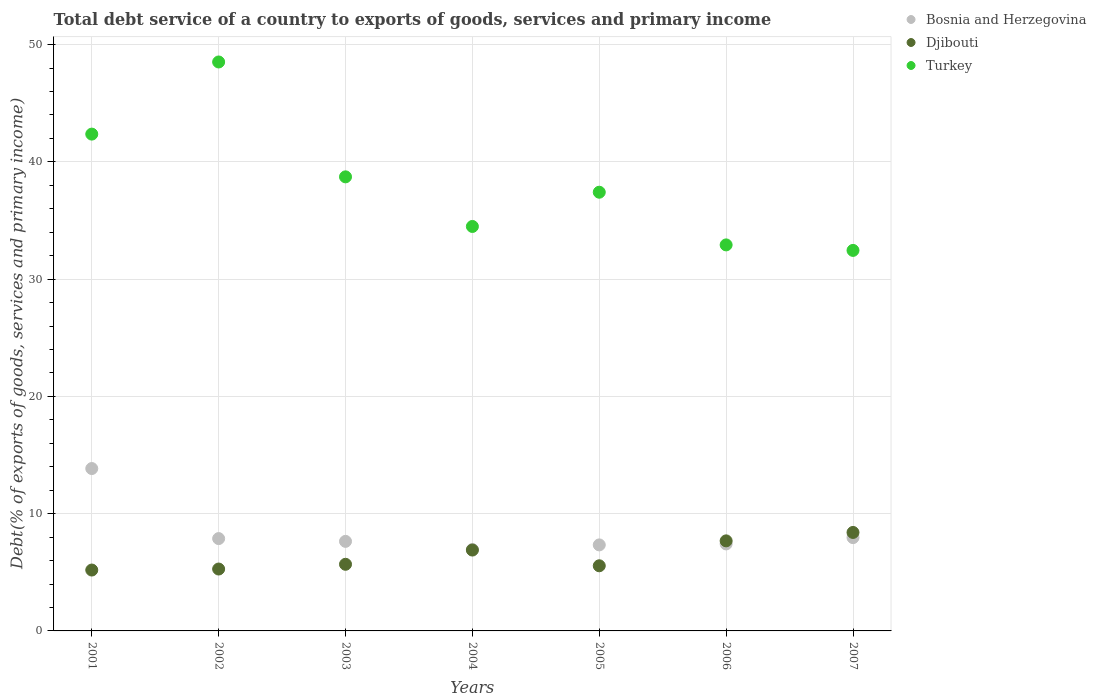How many different coloured dotlines are there?
Give a very brief answer. 3. What is the total debt service in Turkey in 2007?
Ensure brevity in your answer.  32.45. Across all years, what is the maximum total debt service in Bosnia and Herzegovina?
Provide a succinct answer. 13.85. Across all years, what is the minimum total debt service in Bosnia and Herzegovina?
Provide a succinct answer. 6.94. What is the total total debt service in Djibouti in the graph?
Offer a very short reply. 44.68. What is the difference between the total debt service in Bosnia and Herzegovina in 2004 and that in 2005?
Give a very brief answer. -0.39. What is the difference between the total debt service in Bosnia and Herzegovina in 2002 and the total debt service in Turkey in 2005?
Offer a terse response. -29.54. What is the average total debt service in Djibouti per year?
Ensure brevity in your answer.  6.38. In the year 2004, what is the difference between the total debt service in Bosnia and Herzegovina and total debt service in Djibouti?
Provide a succinct answer. 0.05. In how many years, is the total debt service in Bosnia and Herzegovina greater than 30 %?
Ensure brevity in your answer.  0. What is the ratio of the total debt service in Djibouti in 2003 to that in 2006?
Offer a very short reply. 0.74. Is the total debt service in Turkey in 2002 less than that in 2005?
Give a very brief answer. No. What is the difference between the highest and the second highest total debt service in Turkey?
Offer a terse response. 6.15. What is the difference between the highest and the lowest total debt service in Turkey?
Give a very brief answer. 16.07. Is the sum of the total debt service in Turkey in 2002 and 2007 greater than the maximum total debt service in Djibouti across all years?
Your answer should be compact. Yes. Is it the case that in every year, the sum of the total debt service in Djibouti and total debt service in Bosnia and Herzegovina  is greater than the total debt service in Turkey?
Your response must be concise. No. Does the total debt service in Djibouti monotonically increase over the years?
Your response must be concise. No. Is the total debt service in Djibouti strictly greater than the total debt service in Turkey over the years?
Offer a very short reply. No. Does the graph contain any zero values?
Your answer should be very brief. No. Does the graph contain grids?
Offer a very short reply. Yes. Where does the legend appear in the graph?
Your answer should be compact. Top right. How are the legend labels stacked?
Ensure brevity in your answer.  Vertical. What is the title of the graph?
Offer a terse response. Total debt service of a country to exports of goods, services and primary income. What is the label or title of the Y-axis?
Keep it short and to the point. Debt(% of exports of goods, services and primary income). What is the Debt(% of exports of goods, services and primary income) of Bosnia and Herzegovina in 2001?
Keep it short and to the point. 13.85. What is the Debt(% of exports of goods, services and primary income) of Djibouti in 2001?
Offer a terse response. 5.19. What is the Debt(% of exports of goods, services and primary income) of Turkey in 2001?
Your answer should be compact. 42.37. What is the Debt(% of exports of goods, services and primary income) in Bosnia and Herzegovina in 2002?
Your answer should be compact. 7.87. What is the Debt(% of exports of goods, services and primary income) in Djibouti in 2002?
Your answer should be compact. 5.28. What is the Debt(% of exports of goods, services and primary income) in Turkey in 2002?
Your answer should be very brief. 48.52. What is the Debt(% of exports of goods, services and primary income) of Bosnia and Herzegovina in 2003?
Offer a very short reply. 7.64. What is the Debt(% of exports of goods, services and primary income) of Djibouti in 2003?
Your answer should be very brief. 5.68. What is the Debt(% of exports of goods, services and primary income) of Turkey in 2003?
Your answer should be very brief. 38.72. What is the Debt(% of exports of goods, services and primary income) of Bosnia and Herzegovina in 2004?
Provide a succinct answer. 6.94. What is the Debt(% of exports of goods, services and primary income) in Djibouti in 2004?
Your answer should be very brief. 6.9. What is the Debt(% of exports of goods, services and primary income) in Turkey in 2004?
Offer a terse response. 34.49. What is the Debt(% of exports of goods, services and primary income) of Bosnia and Herzegovina in 2005?
Your answer should be very brief. 7.34. What is the Debt(% of exports of goods, services and primary income) in Djibouti in 2005?
Give a very brief answer. 5.55. What is the Debt(% of exports of goods, services and primary income) of Turkey in 2005?
Your answer should be very brief. 37.41. What is the Debt(% of exports of goods, services and primary income) in Bosnia and Herzegovina in 2006?
Offer a terse response. 7.42. What is the Debt(% of exports of goods, services and primary income) of Djibouti in 2006?
Keep it short and to the point. 7.68. What is the Debt(% of exports of goods, services and primary income) of Turkey in 2006?
Provide a succinct answer. 32.92. What is the Debt(% of exports of goods, services and primary income) in Bosnia and Herzegovina in 2007?
Your response must be concise. 7.96. What is the Debt(% of exports of goods, services and primary income) of Djibouti in 2007?
Make the answer very short. 8.4. What is the Debt(% of exports of goods, services and primary income) in Turkey in 2007?
Keep it short and to the point. 32.45. Across all years, what is the maximum Debt(% of exports of goods, services and primary income) in Bosnia and Herzegovina?
Give a very brief answer. 13.85. Across all years, what is the maximum Debt(% of exports of goods, services and primary income) in Djibouti?
Your answer should be very brief. 8.4. Across all years, what is the maximum Debt(% of exports of goods, services and primary income) in Turkey?
Ensure brevity in your answer.  48.52. Across all years, what is the minimum Debt(% of exports of goods, services and primary income) in Bosnia and Herzegovina?
Offer a terse response. 6.94. Across all years, what is the minimum Debt(% of exports of goods, services and primary income) of Djibouti?
Offer a very short reply. 5.19. Across all years, what is the minimum Debt(% of exports of goods, services and primary income) in Turkey?
Offer a very short reply. 32.45. What is the total Debt(% of exports of goods, services and primary income) in Bosnia and Herzegovina in the graph?
Offer a terse response. 59.01. What is the total Debt(% of exports of goods, services and primary income) of Djibouti in the graph?
Provide a succinct answer. 44.68. What is the total Debt(% of exports of goods, services and primary income) of Turkey in the graph?
Offer a terse response. 266.89. What is the difference between the Debt(% of exports of goods, services and primary income) of Bosnia and Herzegovina in 2001 and that in 2002?
Provide a succinct answer. 5.97. What is the difference between the Debt(% of exports of goods, services and primary income) of Djibouti in 2001 and that in 2002?
Offer a terse response. -0.09. What is the difference between the Debt(% of exports of goods, services and primary income) in Turkey in 2001 and that in 2002?
Give a very brief answer. -6.15. What is the difference between the Debt(% of exports of goods, services and primary income) in Bosnia and Herzegovina in 2001 and that in 2003?
Provide a succinct answer. 6.21. What is the difference between the Debt(% of exports of goods, services and primary income) of Djibouti in 2001 and that in 2003?
Your response must be concise. -0.49. What is the difference between the Debt(% of exports of goods, services and primary income) in Turkey in 2001 and that in 2003?
Ensure brevity in your answer.  3.64. What is the difference between the Debt(% of exports of goods, services and primary income) in Bosnia and Herzegovina in 2001 and that in 2004?
Your answer should be very brief. 6.9. What is the difference between the Debt(% of exports of goods, services and primary income) of Djibouti in 2001 and that in 2004?
Provide a short and direct response. -1.7. What is the difference between the Debt(% of exports of goods, services and primary income) of Turkey in 2001 and that in 2004?
Your response must be concise. 7.88. What is the difference between the Debt(% of exports of goods, services and primary income) in Bosnia and Herzegovina in 2001 and that in 2005?
Give a very brief answer. 6.51. What is the difference between the Debt(% of exports of goods, services and primary income) of Djibouti in 2001 and that in 2005?
Your answer should be very brief. -0.36. What is the difference between the Debt(% of exports of goods, services and primary income) in Turkey in 2001 and that in 2005?
Provide a succinct answer. 4.96. What is the difference between the Debt(% of exports of goods, services and primary income) of Bosnia and Herzegovina in 2001 and that in 2006?
Your answer should be compact. 6.43. What is the difference between the Debt(% of exports of goods, services and primary income) in Djibouti in 2001 and that in 2006?
Offer a very short reply. -2.49. What is the difference between the Debt(% of exports of goods, services and primary income) in Turkey in 2001 and that in 2006?
Provide a short and direct response. 9.45. What is the difference between the Debt(% of exports of goods, services and primary income) of Bosnia and Herzegovina in 2001 and that in 2007?
Offer a very short reply. 5.89. What is the difference between the Debt(% of exports of goods, services and primary income) of Djibouti in 2001 and that in 2007?
Your response must be concise. -3.21. What is the difference between the Debt(% of exports of goods, services and primary income) in Turkey in 2001 and that in 2007?
Make the answer very short. 9.92. What is the difference between the Debt(% of exports of goods, services and primary income) in Bosnia and Herzegovina in 2002 and that in 2003?
Provide a succinct answer. 0.24. What is the difference between the Debt(% of exports of goods, services and primary income) in Djibouti in 2002 and that in 2003?
Provide a succinct answer. -0.4. What is the difference between the Debt(% of exports of goods, services and primary income) in Turkey in 2002 and that in 2003?
Offer a terse response. 9.8. What is the difference between the Debt(% of exports of goods, services and primary income) in Bosnia and Herzegovina in 2002 and that in 2004?
Provide a short and direct response. 0.93. What is the difference between the Debt(% of exports of goods, services and primary income) in Djibouti in 2002 and that in 2004?
Ensure brevity in your answer.  -1.62. What is the difference between the Debt(% of exports of goods, services and primary income) in Turkey in 2002 and that in 2004?
Offer a terse response. 14.03. What is the difference between the Debt(% of exports of goods, services and primary income) in Bosnia and Herzegovina in 2002 and that in 2005?
Ensure brevity in your answer.  0.54. What is the difference between the Debt(% of exports of goods, services and primary income) in Djibouti in 2002 and that in 2005?
Keep it short and to the point. -0.28. What is the difference between the Debt(% of exports of goods, services and primary income) of Turkey in 2002 and that in 2005?
Provide a short and direct response. 11.11. What is the difference between the Debt(% of exports of goods, services and primary income) of Bosnia and Herzegovina in 2002 and that in 2006?
Your answer should be very brief. 0.46. What is the difference between the Debt(% of exports of goods, services and primary income) of Djibouti in 2002 and that in 2006?
Provide a short and direct response. -2.4. What is the difference between the Debt(% of exports of goods, services and primary income) in Turkey in 2002 and that in 2006?
Your response must be concise. 15.6. What is the difference between the Debt(% of exports of goods, services and primary income) of Bosnia and Herzegovina in 2002 and that in 2007?
Your answer should be very brief. -0.08. What is the difference between the Debt(% of exports of goods, services and primary income) of Djibouti in 2002 and that in 2007?
Your answer should be compact. -3.12. What is the difference between the Debt(% of exports of goods, services and primary income) of Turkey in 2002 and that in 2007?
Your answer should be compact. 16.07. What is the difference between the Debt(% of exports of goods, services and primary income) in Bosnia and Herzegovina in 2003 and that in 2004?
Your answer should be compact. 0.69. What is the difference between the Debt(% of exports of goods, services and primary income) of Djibouti in 2003 and that in 2004?
Keep it short and to the point. -1.21. What is the difference between the Debt(% of exports of goods, services and primary income) in Turkey in 2003 and that in 2004?
Ensure brevity in your answer.  4.23. What is the difference between the Debt(% of exports of goods, services and primary income) in Bosnia and Herzegovina in 2003 and that in 2005?
Your answer should be very brief. 0.3. What is the difference between the Debt(% of exports of goods, services and primary income) in Djibouti in 2003 and that in 2005?
Provide a short and direct response. 0.13. What is the difference between the Debt(% of exports of goods, services and primary income) in Turkey in 2003 and that in 2005?
Your answer should be very brief. 1.31. What is the difference between the Debt(% of exports of goods, services and primary income) of Bosnia and Herzegovina in 2003 and that in 2006?
Your answer should be very brief. 0.22. What is the difference between the Debt(% of exports of goods, services and primary income) of Djibouti in 2003 and that in 2006?
Your answer should be compact. -2. What is the difference between the Debt(% of exports of goods, services and primary income) of Turkey in 2003 and that in 2006?
Make the answer very short. 5.8. What is the difference between the Debt(% of exports of goods, services and primary income) of Bosnia and Herzegovina in 2003 and that in 2007?
Your answer should be very brief. -0.32. What is the difference between the Debt(% of exports of goods, services and primary income) in Djibouti in 2003 and that in 2007?
Your answer should be very brief. -2.72. What is the difference between the Debt(% of exports of goods, services and primary income) of Turkey in 2003 and that in 2007?
Give a very brief answer. 6.27. What is the difference between the Debt(% of exports of goods, services and primary income) in Bosnia and Herzegovina in 2004 and that in 2005?
Provide a short and direct response. -0.39. What is the difference between the Debt(% of exports of goods, services and primary income) of Djibouti in 2004 and that in 2005?
Your response must be concise. 1.34. What is the difference between the Debt(% of exports of goods, services and primary income) of Turkey in 2004 and that in 2005?
Provide a succinct answer. -2.92. What is the difference between the Debt(% of exports of goods, services and primary income) in Bosnia and Herzegovina in 2004 and that in 2006?
Your answer should be very brief. -0.47. What is the difference between the Debt(% of exports of goods, services and primary income) in Djibouti in 2004 and that in 2006?
Keep it short and to the point. -0.78. What is the difference between the Debt(% of exports of goods, services and primary income) in Turkey in 2004 and that in 2006?
Keep it short and to the point. 1.57. What is the difference between the Debt(% of exports of goods, services and primary income) of Bosnia and Herzegovina in 2004 and that in 2007?
Give a very brief answer. -1.01. What is the difference between the Debt(% of exports of goods, services and primary income) of Djibouti in 2004 and that in 2007?
Your answer should be very brief. -1.5. What is the difference between the Debt(% of exports of goods, services and primary income) in Turkey in 2004 and that in 2007?
Your answer should be very brief. 2.04. What is the difference between the Debt(% of exports of goods, services and primary income) of Bosnia and Herzegovina in 2005 and that in 2006?
Provide a succinct answer. -0.08. What is the difference between the Debt(% of exports of goods, services and primary income) of Djibouti in 2005 and that in 2006?
Make the answer very short. -2.13. What is the difference between the Debt(% of exports of goods, services and primary income) in Turkey in 2005 and that in 2006?
Provide a short and direct response. 4.49. What is the difference between the Debt(% of exports of goods, services and primary income) of Bosnia and Herzegovina in 2005 and that in 2007?
Offer a very short reply. -0.62. What is the difference between the Debt(% of exports of goods, services and primary income) in Djibouti in 2005 and that in 2007?
Offer a very short reply. -2.84. What is the difference between the Debt(% of exports of goods, services and primary income) of Turkey in 2005 and that in 2007?
Offer a terse response. 4.96. What is the difference between the Debt(% of exports of goods, services and primary income) in Bosnia and Herzegovina in 2006 and that in 2007?
Provide a short and direct response. -0.54. What is the difference between the Debt(% of exports of goods, services and primary income) in Djibouti in 2006 and that in 2007?
Make the answer very short. -0.72. What is the difference between the Debt(% of exports of goods, services and primary income) in Turkey in 2006 and that in 2007?
Your response must be concise. 0.47. What is the difference between the Debt(% of exports of goods, services and primary income) in Bosnia and Herzegovina in 2001 and the Debt(% of exports of goods, services and primary income) in Djibouti in 2002?
Offer a terse response. 8.57. What is the difference between the Debt(% of exports of goods, services and primary income) of Bosnia and Herzegovina in 2001 and the Debt(% of exports of goods, services and primary income) of Turkey in 2002?
Your answer should be compact. -34.67. What is the difference between the Debt(% of exports of goods, services and primary income) in Djibouti in 2001 and the Debt(% of exports of goods, services and primary income) in Turkey in 2002?
Offer a very short reply. -43.33. What is the difference between the Debt(% of exports of goods, services and primary income) of Bosnia and Herzegovina in 2001 and the Debt(% of exports of goods, services and primary income) of Djibouti in 2003?
Provide a succinct answer. 8.17. What is the difference between the Debt(% of exports of goods, services and primary income) of Bosnia and Herzegovina in 2001 and the Debt(% of exports of goods, services and primary income) of Turkey in 2003?
Your response must be concise. -24.88. What is the difference between the Debt(% of exports of goods, services and primary income) in Djibouti in 2001 and the Debt(% of exports of goods, services and primary income) in Turkey in 2003?
Give a very brief answer. -33.53. What is the difference between the Debt(% of exports of goods, services and primary income) of Bosnia and Herzegovina in 2001 and the Debt(% of exports of goods, services and primary income) of Djibouti in 2004?
Offer a terse response. 6.95. What is the difference between the Debt(% of exports of goods, services and primary income) of Bosnia and Herzegovina in 2001 and the Debt(% of exports of goods, services and primary income) of Turkey in 2004?
Your answer should be compact. -20.64. What is the difference between the Debt(% of exports of goods, services and primary income) in Djibouti in 2001 and the Debt(% of exports of goods, services and primary income) in Turkey in 2004?
Ensure brevity in your answer.  -29.3. What is the difference between the Debt(% of exports of goods, services and primary income) in Bosnia and Herzegovina in 2001 and the Debt(% of exports of goods, services and primary income) in Djibouti in 2005?
Give a very brief answer. 8.29. What is the difference between the Debt(% of exports of goods, services and primary income) in Bosnia and Herzegovina in 2001 and the Debt(% of exports of goods, services and primary income) in Turkey in 2005?
Offer a terse response. -23.56. What is the difference between the Debt(% of exports of goods, services and primary income) of Djibouti in 2001 and the Debt(% of exports of goods, services and primary income) of Turkey in 2005?
Keep it short and to the point. -32.22. What is the difference between the Debt(% of exports of goods, services and primary income) of Bosnia and Herzegovina in 2001 and the Debt(% of exports of goods, services and primary income) of Djibouti in 2006?
Your answer should be very brief. 6.17. What is the difference between the Debt(% of exports of goods, services and primary income) in Bosnia and Herzegovina in 2001 and the Debt(% of exports of goods, services and primary income) in Turkey in 2006?
Offer a very short reply. -19.07. What is the difference between the Debt(% of exports of goods, services and primary income) of Djibouti in 2001 and the Debt(% of exports of goods, services and primary income) of Turkey in 2006?
Your answer should be compact. -27.73. What is the difference between the Debt(% of exports of goods, services and primary income) of Bosnia and Herzegovina in 2001 and the Debt(% of exports of goods, services and primary income) of Djibouti in 2007?
Provide a succinct answer. 5.45. What is the difference between the Debt(% of exports of goods, services and primary income) in Bosnia and Herzegovina in 2001 and the Debt(% of exports of goods, services and primary income) in Turkey in 2007?
Your answer should be very brief. -18.6. What is the difference between the Debt(% of exports of goods, services and primary income) in Djibouti in 2001 and the Debt(% of exports of goods, services and primary income) in Turkey in 2007?
Provide a short and direct response. -27.26. What is the difference between the Debt(% of exports of goods, services and primary income) of Bosnia and Herzegovina in 2002 and the Debt(% of exports of goods, services and primary income) of Djibouti in 2003?
Give a very brief answer. 2.19. What is the difference between the Debt(% of exports of goods, services and primary income) of Bosnia and Herzegovina in 2002 and the Debt(% of exports of goods, services and primary income) of Turkey in 2003?
Your response must be concise. -30.85. What is the difference between the Debt(% of exports of goods, services and primary income) of Djibouti in 2002 and the Debt(% of exports of goods, services and primary income) of Turkey in 2003?
Your response must be concise. -33.45. What is the difference between the Debt(% of exports of goods, services and primary income) in Bosnia and Herzegovina in 2002 and the Debt(% of exports of goods, services and primary income) in Djibouti in 2004?
Give a very brief answer. 0.98. What is the difference between the Debt(% of exports of goods, services and primary income) in Bosnia and Herzegovina in 2002 and the Debt(% of exports of goods, services and primary income) in Turkey in 2004?
Make the answer very short. -26.62. What is the difference between the Debt(% of exports of goods, services and primary income) of Djibouti in 2002 and the Debt(% of exports of goods, services and primary income) of Turkey in 2004?
Provide a succinct answer. -29.21. What is the difference between the Debt(% of exports of goods, services and primary income) in Bosnia and Herzegovina in 2002 and the Debt(% of exports of goods, services and primary income) in Djibouti in 2005?
Make the answer very short. 2.32. What is the difference between the Debt(% of exports of goods, services and primary income) of Bosnia and Herzegovina in 2002 and the Debt(% of exports of goods, services and primary income) of Turkey in 2005?
Your answer should be very brief. -29.54. What is the difference between the Debt(% of exports of goods, services and primary income) in Djibouti in 2002 and the Debt(% of exports of goods, services and primary income) in Turkey in 2005?
Provide a succinct answer. -32.13. What is the difference between the Debt(% of exports of goods, services and primary income) in Bosnia and Herzegovina in 2002 and the Debt(% of exports of goods, services and primary income) in Djibouti in 2006?
Offer a very short reply. 0.19. What is the difference between the Debt(% of exports of goods, services and primary income) of Bosnia and Herzegovina in 2002 and the Debt(% of exports of goods, services and primary income) of Turkey in 2006?
Ensure brevity in your answer.  -25.05. What is the difference between the Debt(% of exports of goods, services and primary income) of Djibouti in 2002 and the Debt(% of exports of goods, services and primary income) of Turkey in 2006?
Make the answer very short. -27.64. What is the difference between the Debt(% of exports of goods, services and primary income) in Bosnia and Herzegovina in 2002 and the Debt(% of exports of goods, services and primary income) in Djibouti in 2007?
Your answer should be very brief. -0.52. What is the difference between the Debt(% of exports of goods, services and primary income) in Bosnia and Herzegovina in 2002 and the Debt(% of exports of goods, services and primary income) in Turkey in 2007?
Your response must be concise. -24.58. What is the difference between the Debt(% of exports of goods, services and primary income) in Djibouti in 2002 and the Debt(% of exports of goods, services and primary income) in Turkey in 2007?
Keep it short and to the point. -27.17. What is the difference between the Debt(% of exports of goods, services and primary income) of Bosnia and Herzegovina in 2003 and the Debt(% of exports of goods, services and primary income) of Djibouti in 2004?
Your answer should be compact. 0.74. What is the difference between the Debt(% of exports of goods, services and primary income) in Bosnia and Herzegovina in 2003 and the Debt(% of exports of goods, services and primary income) in Turkey in 2004?
Offer a terse response. -26.86. What is the difference between the Debt(% of exports of goods, services and primary income) of Djibouti in 2003 and the Debt(% of exports of goods, services and primary income) of Turkey in 2004?
Offer a very short reply. -28.81. What is the difference between the Debt(% of exports of goods, services and primary income) of Bosnia and Herzegovina in 2003 and the Debt(% of exports of goods, services and primary income) of Djibouti in 2005?
Provide a short and direct response. 2.08. What is the difference between the Debt(% of exports of goods, services and primary income) of Bosnia and Herzegovina in 2003 and the Debt(% of exports of goods, services and primary income) of Turkey in 2005?
Ensure brevity in your answer.  -29.78. What is the difference between the Debt(% of exports of goods, services and primary income) in Djibouti in 2003 and the Debt(% of exports of goods, services and primary income) in Turkey in 2005?
Give a very brief answer. -31.73. What is the difference between the Debt(% of exports of goods, services and primary income) of Bosnia and Herzegovina in 2003 and the Debt(% of exports of goods, services and primary income) of Djibouti in 2006?
Your response must be concise. -0.04. What is the difference between the Debt(% of exports of goods, services and primary income) in Bosnia and Herzegovina in 2003 and the Debt(% of exports of goods, services and primary income) in Turkey in 2006?
Your response must be concise. -25.28. What is the difference between the Debt(% of exports of goods, services and primary income) in Djibouti in 2003 and the Debt(% of exports of goods, services and primary income) in Turkey in 2006?
Your response must be concise. -27.24. What is the difference between the Debt(% of exports of goods, services and primary income) of Bosnia and Herzegovina in 2003 and the Debt(% of exports of goods, services and primary income) of Djibouti in 2007?
Offer a very short reply. -0.76. What is the difference between the Debt(% of exports of goods, services and primary income) of Bosnia and Herzegovina in 2003 and the Debt(% of exports of goods, services and primary income) of Turkey in 2007?
Your answer should be compact. -24.81. What is the difference between the Debt(% of exports of goods, services and primary income) in Djibouti in 2003 and the Debt(% of exports of goods, services and primary income) in Turkey in 2007?
Your answer should be very brief. -26.77. What is the difference between the Debt(% of exports of goods, services and primary income) in Bosnia and Herzegovina in 2004 and the Debt(% of exports of goods, services and primary income) in Djibouti in 2005?
Give a very brief answer. 1.39. What is the difference between the Debt(% of exports of goods, services and primary income) of Bosnia and Herzegovina in 2004 and the Debt(% of exports of goods, services and primary income) of Turkey in 2005?
Provide a succinct answer. -30.47. What is the difference between the Debt(% of exports of goods, services and primary income) of Djibouti in 2004 and the Debt(% of exports of goods, services and primary income) of Turkey in 2005?
Offer a terse response. -30.52. What is the difference between the Debt(% of exports of goods, services and primary income) of Bosnia and Herzegovina in 2004 and the Debt(% of exports of goods, services and primary income) of Djibouti in 2006?
Provide a short and direct response. -0.74. What is the difference between the Debt(% of exports of goods, services and primary income) in Bosnia and Herzegovina in 2004 and the Debt(% of exports of goods, services and primary income) in Turkey in 2006?
Make the answer very short. -25.98. What is the difference between the Debt(% of exports of goods, services and primary income) of Djibouti in 2004 and the Debt(% of exports of goods, services and primary income) of Turkey in 2006?
Provide a succinct answer. -26.02. What is the difference between the Debt(% of exports of goods, services and primary income) in Bosnia and Herzegovina in 2004 and the Debt(% of exports of goods, services and primary income) in Djibouti in 2007?
Your response must be concise. -1.45. What is the difference between the Debt(% of exports of goods, services and primary income) of Bosnia and Herzegovina in 2004 and the Debt(% of exports of goods, services and primary income) of Turkey in 2007?
Your answer should be very brief. -25.51. What is the difference between the Debt(% of exports of goods, services and primary income) of Djibouti in 2004 and the Debt(% of exports of goods, services and primary income) of Turkey in 2007?
Provide a succinct answer. -25.55. What is the difference between the Debt(% of exports of goods, services and primary income) of Bosnia and Herzegovina in 2005 and the Debt(% of exports of goods, services and primary income) of Djibouti in 2006?
Offer a very short reply. -0.34. What is the difference between the Debt(% of exports of goods, services and primary income) in Bosnia and Herzegovina in 2005 and the Debt(% of exports of goods, services and primary income) in Turkey in 2006?
Your response must be concise. -25.58. What is the difference between the Debt(% of exports of goods, services and primary income) in Djibouti in 2005 and the Debt(% of exports of goods, services and primary income) in Turkey in 2006?
Give a very brief answer. -27.36. What is the difference between the Debt(% of exports of goods, services and primary income) in Bosnia and Herzegovina in 2005 and the Debt(% of exports of goods, services and primary income) in Djibouti in 2007?
Make the answer very short. -1.06. What is the difference between the Debt(% of exports of goods, services and primary income) in Bosnia and Herzegovina in 2005 and the Debt(% of exports of goods, services and primary income) in Turkey in 2007?
Your answer should be compact. -25.12. What is the difference between the Debt(% of exports of goods, services and primary income) of Djibouti in 2005 and the Debt(% of exports of goods, services and primary income) of Turkey in 2007?
Your answer should be compact. -26.9. What is the difference between the Debt(% of exports of goods, services and primary income) in Bosnia and Herzegovina in 2006 and the Debt(% of exports of goods, services and primary income) in Djibouti in 2007?
Provide a short and direct response. -0.98. What is the difference between the Debt(% of exports of goods, services and primary income) in Bosnia and Herzegovina in 2006 and the Debt(% of exports of goods, services and primary income) in Turkey in 2007?
Provide a short and direct response. -25.03. What is the difference between the Debt(% of exports of goods, services and primary income) in Djibouti in 2006 and the Debt(% of exports of goods, services and primary income) in Turkey in 2007?
Ensure brevity in your answer.  -24.77. What is the average Debt(% of exports of goods, services and primary income) in Bosnia and Herzegovina per year?
Provide a succinct answer. 8.43. What is the average Debt(% of exports of goods, services and primary income) in Djibouti per year?
Ensure brevity in your answer.  6.38. What is the average Debt(% of exports of goods, services and primary income) in Turkey per year?
Give a very brief answer. 38.13. In the year 2001, what is the difference between the Debt(% of exports of goods, services and primary income) in Bosnia and Herzegovina and Debt(% of exports of goods, services and primary income) in Djibouti?
Provide a short and direct response. 8.66. In the year 2001, what is the difference between the Debt(% of exports of goods, services and primary income) in Bosnia and Herzegovina and Debt(% of exports of goods, services and primary income) in Turkey?
Provide a short and direct response. -28.52. In the year 2001, what is the difference between the Debt(% of exports of goods, services and primary income) in Djibouti and Debt(% of exports of goods, services and primary income) in Turkey?
Offer a terse response. -37.18. In the year 2002, what is the difference between the Debt(% of exports of goods, services and primary income) of Bosnia and Herzegovina and Debt(% of exports of goods, services and primary income) of Djibouti?
Offer a very short reply. 2.6. In the year 2002, what is the difference between the Debt(% of exports of goods, services and primary income) of Bosnia and Herzegovina and Debt(% of exports of goods, services and primary income) of Turkey?
Give a very brief answer. -40.65. In the year 2002, what is the difference between the Debt(% of exports of goods, services and primary income) of Djibouti and Debt(% of exports of goods, services and primary income) of Turkey?
Make the answer very short. -43.24. In the year 2003, what is the difference between the Debt(% of exports of goods, services and primary income) in Bosnia and Herzegovina and Debt(% of exports of goods, services and primary income) in Djibouti?
Keep it short and to the point. 1.95. In the year 2003, what is the difference between the Debt(% of exports of goods, services and primary income) of Bosnia and Herzegovina and Debt(% of exports of goods, services and primary income) of Turkey?
Your answer should be compact. -31.09. In the year 2003, what is the difference between the Debt(% of exports of goods, services and primary income) of Djibouti and Debt(% of exports of goods, services and primary income) of Turkey?
Offer a terse response. -33.04. In the year 2004, what is the difference between the Debt(% of exports of goods, services and primary income) in Bosnia and Herzegovina and Debt(% of exports of goods, services and primary income) in Djibouti?
Your answer should be compact. 0.05. In the year 2004, what is the difference between the Debt(% of exports of goods, services and primary income) in Bosnia and Herzegovina and Debt(% of exports of goods, services and primary income) in Turkey?
Your answer should be very brief. -27.55. In the year 2004, what is the difference between the Debt(% of exports of goods, services and primary income) of Djibouti and Debt(% of exports of goods, services and primary income) of Turkey?
Keep it short and to the point. -27.6. In the year 2005, what is the difference between the Debt(% of exports of goods, services and primary income) of Bosnia and Herzegovina and Debt(% of exports of goods, services and primary income) of Djibouti?
Make the answer very short. 1.78. In the year 2005, what is the difference between the Debt(% of exports of goods, services and primary income) in Bosnia and Herzegovina and Debt(% of exports of goods, services and primary income) in Turkey?
Your answer should be very brief. -30.08. In the year 2005, what is the difference between the Debt(% of exports of goods, services and primary income) of Djibouti and Debt(% of exports of goods, services and primary income) of Turkey?
Your response must be concise. -31.86. In the year 2006, what is the difference between the Debt(% of exports of goods, services and primary income) in Bosnia and Herzegovina and Debt(% of exports of goods, services and primary income) in Djibouti?
Provide a short and direct response. -0.26. In the year 2006, what is the difference between the Debt(% of exports of goods, services and primary income) in Bosnia and Herzegovina and Debt(% of exports of goods, services and primary income) in Turkey?
Keep it short and to the point. -25.5. In the year 2006, what is the difference between the Debt(% of exports of goods, services and primary income) in Djibouti and Debt(% of exports of goods, services and primary income) in Turkey?
Provide a succinct answer. -25.24. In the year 2007, what is the difference between the Debt(% of exports of goods, services and primary income) in Bosnia and Herzegovina and Debt(% of exports of goods, services and primary income) in Djibouti?
Provide a succinct answer. -0.44. In the year 2007, what is the difference between the Debt(% of exports of goods, services and primary income) in Bosnia and Herzegovina and Debt(% of exports of goods, services and primary income) in Turkey?
Offer a terse response. -24.49. In the year 2007, what is the difference between the Debt(% of exports of goods, services and primary income) in Djibouti and Debt(% of exports of goods, services and primary income) in Turkey?
Your answer should be compact. -24.05. What is the ratio of the Debt(% of exports of goods, services and primary income) in Bosnia and Herzegovina in 2001 to that in 2002?
Your answer should be very brief. 1.76. What is the ratio of the Debt(% of exports of goods, services and primary income) of Djibouti in 2001 to that in 2002?
Your response must be concise. 0.98. What is the ratio of the Debt(% of exports of goods, services and primary income) of Turkey in 2001 to that in 2002?
Offer a very short reply. 0.87. What is the ratio of the Debt(% of exports of goods, services and primary income) in Bosnia and Herzegovina in 2001 to that in 2003?
Ensure brevity in your answer.  1.81. What is the ratio of the Debt(% of exports of goods, services and primary income) of Djibouti in 2001 to that in 2003?
Ensure brevity in your answer.  0.91. What is the ratio of the Debt(% of exports of goods, services and primary income) of Turkey in 2001 to that in 2003?
Ensure brevity in your answer.  1.09. What is the ratio of the Debt(% of exports of goods, services and primary income) in Bosnia and Herzegovina in 2001 to that in 2004?
Your answer should be compact. 1.99. What is the ratio of the Debt(% of exports of goods, services and primary income) in Djibouti in 2001 to that in 2004?
Provide a short and direct response. 0.75. What is the ratio of the Debt(% of exports of goods, services and primary income) of Turkey in 2001 to that in 2004?
Offer a very short reply. 1.23. What is the ratio of the Debt(% of exports of goods, services and primary income) of Bosnia and Herzegovina in 2001 to that in 2005?
Your answer should be very brief. 1.89. What is the ratio of the Debt(% of exports of goods, services and primary income) in Djibouti in 2001 to that in 2005?
Your answer should be very brief. 0.93. What is the ratio of the Debt(% of exports of goods, services and primary income) of Turkey in 2001 to that in 2005?
Provide a succinct answer. 1.13. What is the ratio of the Debt(% of exports of goods, services and primary income) of Bosnia and Herzegovina in 2001 to that in 2006?
Provide a short and direct response. 1.87. What is the ratio of the Debt(% of exports of goods, services and primary income) of Djibouti in 2001 to that in 2006?
Your response must be concise. 0.68. What is the ratio of the Debt(% of exports of goods, services and primary income) of Turkey in 2001 to that in 2006?
Offer a terse response. 1.29. What is the ratio of the Debt(% of exports of goods, services and primary income) in Bosnia and Herzegovina in 2001 to that in 2007?
Your response must be concise. 1.74. What is the ratio of the Debt(% of exports of goods, services and primary income) of Djibouti in 2001 to that in 2007?
Make the answer very short. 0.62. What is the ratio of the Debt(% of exports of goods, services and primary income) of Turkey in 2001 to that in 2007?
Provide a short and direct response. 1.31. What is the ratio of the Debt(% of exports of goods, services and primary income) in Bosnia and Herzegovina in 2002 to that in 2003?
Make the answer very short. 1.03. What is the ratio of the Debt(% of exports of goods, services and primary income) of Djibouti in 2002 to that in 2003?
Provide a succinct answer. 0.93. What is the ratio of the Debt(% of exports of goods, services and primary income) in Turkey in 2002 to that in 2003?
Your response must be concise. 1.25. What is the ratio of the Debt(% of exports of goods, services and primary income) of Bosnia and Herzegovina in 2002 to that in 2004?
Make the answer very short. 1.13. What is the ratio of the Debt(% of exports of goods, services and primary income) of Djibouti in 2002 to that in 2004?
Give a very brief answer. 0.77. What is the ratio of the Debt(% of exports of goods, services and primary income) in Turkey in 2002 to that in 2004?
Your response must be concise. 1.41. What is the ratio of the Debt(% of exports of goods, services and primary income) of Bosnia and Herzegovina in 2002 to that in 2005?
Your answer should be very brief. 1.07. What is the ratio of the Debt(% of exports of goods, services and primary income) of Djibouti in 2002 to that in 2005?
Ensure brevity in your answer.  0.95. What is the ratio of the Debt(% of exports of goods, services and primary income) in Turkey in 2002 to that in 2005?
Ensure brevity in your answer.  1.3. What is the ratio of the Debt(% of exports of goods, services and primary income) of Bosnia and Herzegovina in 2002 to that in 2006?
Keep it short and to the point. 1.06. What is the ratio of the Debt(% of exports of goods, services and primary income) of Djibouti in 2002 to that in 2006?
Offer a terse response. 0.69. What is the ratio of the Debt(% of exports of goods, services and primary income) in Turkey in 2002 to that in 2006?
Your answer should be compact. 1.47. What is the ratio of the Debt(% of exports of goods, services and primary income) in Bosnia and Herzegovina in 2002 to that in 2007?
Ensure brevity in your answer.  0.99. What is the ratio of the Debt(% of exports of goods, services and primary income) of Djibouti in 2002 to that in 2007?
Your answer should be very brief. 0.63. What is the ratio of the Debt(% of exports of goods, services and primary income) in Turkey in 2002 to that in 2007?
Provide a short and direct response. 1.5. What is the ratio of the Debt(% of exports of goods, services and primary income) in Bosnia and Herzegovina in 2003 to that in 2004?
Ensure brevity in your answer.  1.1. What is the ratio of the Debt(% of exports of goods, services and primary income) in Djibouti in 2003 to that in 2004?
Your answer should be compact. 0.82. What is the ratio of the Debt(% of exports of goods, services and primary income) in Turkey in 2003 to that in 2004?
Your answer should be very brief. 1.12. What is the ratio of the Debt(% of exports of goods, services and primary income) in Bosnia and Herzegovina in 2003 to that in 2005?
Provide a short and direct response. 1.04. What is the ratio of the Debt(% of exports of goods, services and primary income) in Turkey in 2003 to that in 2005?
Your answer should be very brief. 1.03. What is the ratio of the Debt(% of exports of goods, services and primary income) of Bosnia and Herzegovina in 2003 to that in 2006?
Make the answer very short. 1.03. What is the ratio of the Debt(% of exports of goods, services and primary income) in Djibouti in 2003 to that in 2006?
Make the answer very short. 0.74. What is the ratio of the Debt(% of exports of goods, services and primary income) in Turkey in 2003 to that in 2006?
Provide a short and direct response. 1.18. What is the ratio of the Debt(% of exports of goods, services and primary income) in Bosnia and Herzegovina in 2003 to that in 2007?
Make the answer very short. 0.96. What is the ratio of the Debt(% of exports of goods, services and primary income) in Djibouti in 2003 to that in 2007?
Make the answer very short. 0.68. What is the ratio of the Debt(% of exports of goods, services and primary income) in Turkey in 2003 to that in 2007?
Make the answer very short. 1.19. What is the ratio of the Debt(% of exports of goods, services and primary income) in Bosnia and Herzegovina in 2004 to that in 2005?
Provide a short and direct response. 0.95. What is the ratio of the Debt(% of exports of goods, services and primary income) in Djibouti in 2004 to that in 2005?
Your response must be concise. 1.24. What is the ratio of the Debt(% of exports of goods, services and primary income) in Turkey in 2004 to that in 2005?
Your response must be concise. 0.92. What is the ratio of the Debt(% of exports of goods, services and primary income) of Bosnia and Herzegovina in 2004 to that in 2006?
Provide a short and direct response. 0.94. What is the ratio of the Debt(% of exports of goods, services and primary income) of Djibouti in 2004 to that in 2006?
Your response must be concise. 0.9. What is the ratio of the Debt(% of exports of goods, services and primary income) in Turkey in 2004 to that in 2006?
Your answer should be compact. 1.05. What is the ratio of the Debt(% of exports of goods, services and primary income) of Bosnia and Herzegovina in 2004 to that in 2007?
Keep it short and to the point. 0.87. What is the ratio of the Debt(% of exports of goods, services and primary income) in Djibouti in 2004 to that in 2007?
Make the answer very short. 0.82. What is the ratio of the Debt(% of exports of goods, services and primary income) of Turkey in 2004 to that in 2007?
Keep it short and to the point. 1.06. What is the ratio of the Debt(% of exports of goods, services and primary income) of Djibouti in 2005 to that in 2006?
Ensure brevity in your answer.  0.72. What is the ratio of the Debt(% of exports of goods, services and primary income) in Turkey in 2005 to that in 2006?
Make the answer very short. 1.14. What is the ratio of the Debt(% of exports of goods, services and primary income) in Bosnia and Herzegovina in 2005 to that in 2007?
Your response must be concise. 0.92. What is the ratio of the Debt(% of exports of goods, services and primary income) in Djibouti in 2005 to that in 2007?
Provide a succinct answer. 0.66. What is the ratio of the Debt(% of exports of goods, services and primary income) of Turkey in 2005 to that in 2007?
Your answer should be compact. 1.15. What is the ratio of the Debt(% of exports of goods, services and primary income) in Bosnia and Herzegovina in 2006 to that in 2007?
Your answer should be compact. 0.93. What is the ratio of the Debt(% of exports of goods, services and primary income) of Djibouti in 2006 to that in 2007?
Your answer should be compact. 0.91. What is the ratio of the Debt(% of exports of goods, services and primary income) of Turkey in 2006 to that in 2007?
Give a very brief answer. 1.01. What is the difference between the highest and the second highest Debt(% of exports of goods, services and primary income) in Bosnia and Herzegovina?
Your answer should be compact. 5.89. What is the difference between the highest and the second highest Debt(% of exports of goods, services and primary income) of Djibouti?
Provide a succinct answer. 0.72. What is the difference between the highest and the second highest Debt(% of exports of goods, services and primary income) in Turkey?
Offer a very short reply. 6.15. What is the difference between the highest and the lowest Debt(% of exports of goods, services and primary income) of Bosnia and Herzegovina?
Provide a succinct answer. 6.9. What is the difference between the highest and the lowest Debt(% of exports of goods, services and primary income) of Djibouti?
Your answer should be compact. 3.21. What is the difference between the highest and the lowest Debt(% of exports of goods, services and primary income) of Turkey?
Provide a short and direct response. 16.07. 